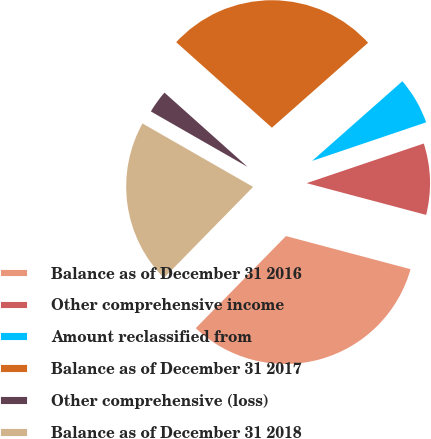Convert chart to OTSL. <chart><loc_0><loc_0><loc_500><loc_500><pie_chart><fcel>Balance as of December 31 2016<fcel>Other comprehensive income<fcel>Amount reclassified from<fcel>Balance as of December 31 2017<fcel>Other comprehensive (loss)<fcel>Balance as of December 31 2018<nl><fcel>33.2%<fcel>9.33%<fcel>6.32%<fcel>26.88%<fcel>3.32%<fcel>20.95%<nl></chart> 